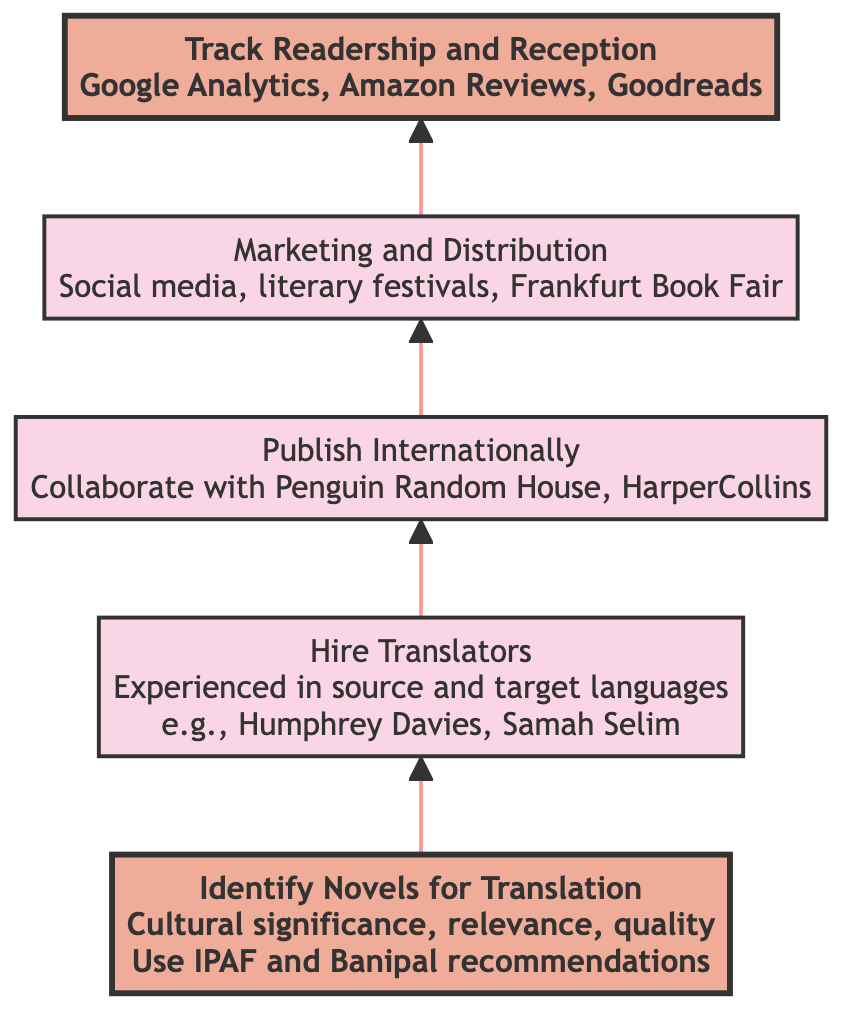What is the first step in the flowchart? The first step in the flowchart is "Identifying Novels for Translation." It is the initial node from which the entire process begins.
Answer: Identifying Novels for Translation How many nodes are present in the diagram? The diagram contains a total of five nodes. Each represents a distinct step in the translation and circulation process.
Answer: 5 Which node follows "Hiring Translators"? The node that follows "Hiring Translators" is "Publish in International Markets." This shows the sequence of actions to be taken after hiring translators.
Answer: Publish in International Markets What tools are recommended for monitoring readership? The tools recommended for monitoring readership include Google Analytics, Amazon Reviews, and Goodreads according to the last node.
Answer: Google Analytics, Amazon Reviews, Goodreads What is the last step in the flowchart? The last step in the flowchart is "Track Readership and Critical Reception." This indicates the final action to assess the outcome of the previous steps.
Answer: Track Readership and Critical Reception Which node is emphasized in the diagram? The nodes emphasized in the diagram are "Identifying Novels for Translation" and "Track Readership and Reception," both of which have a special highlighting compared to the others.
Answer: Identifying Novels for Translation, Track Readership and Reception Describe the relationship between "Marketing and Distribution" and "Publish in International Markets." "Marketing and Distribution" directly follows "Publish in International Markets," showing that once novels are published, the focus shifts to marketing and distribution strategies.
Answer: Directly follows List two criteria for "Identifying Novels for Translation". The two criteria for identifying novels for translation include cultural significance and literary quality as mentioned in the description of that node.
Answer: Cultural significance, literary quality What notable translators are mentioned in the flowchart? The notable translators mentioned are Humphrey Davies and Samah Selim, who are referenced in the "Hiring Translators" step.
Answer: Humphrey Davies, Samah Selim 